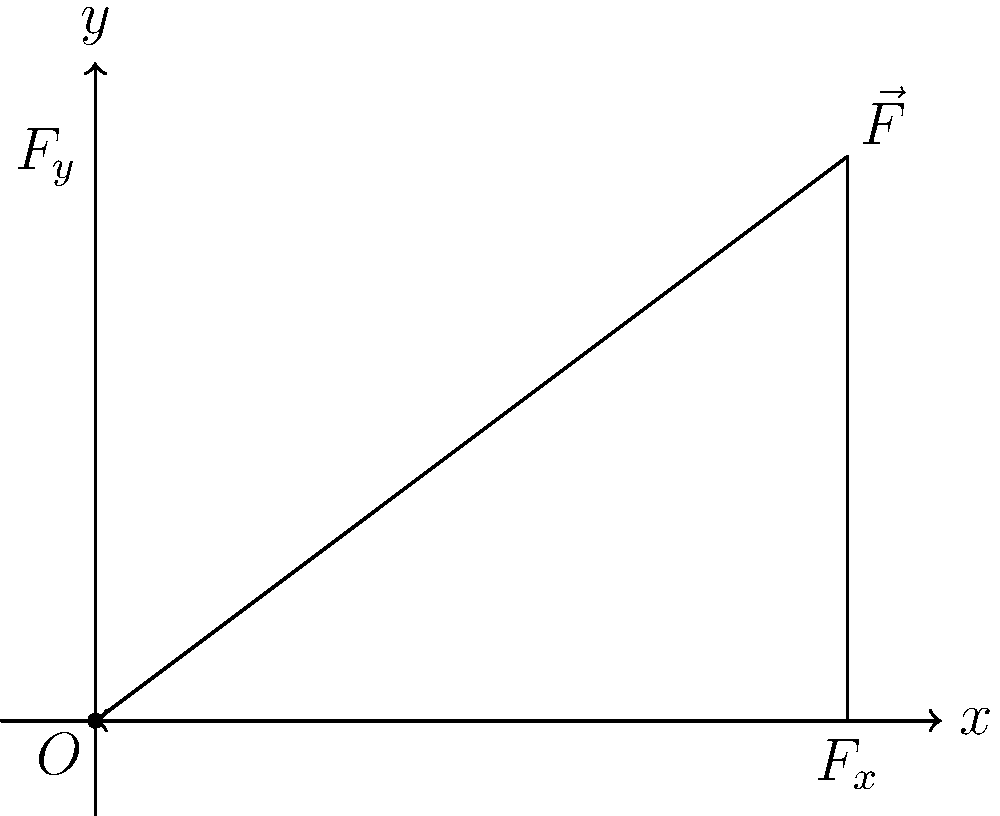As a scientist familiar with vector analysis, consider a force vector $\vec{F}$ with magnitude 5 N acting at an angle of 36.87° above the horizontal, as shown in the figure. Determine the magnitudes of its orthogonal components $F_x$ and $F_y$. To solve this problem, we'll use the trigonometric decomposition of vectors:

1) First, recall the trigonometric relationships for right triangles:
   $\cos \theta = \frac{\text{adjacent}}{\text{hypotenuse}}$ and $\sin \theta = \frac{\text{opposite}}{\text{hypotenuse}}$

2) In this case:
   $|\vec{F}| = 5$ N (hypotenuse)
   $\theta = 36.87°$
   $F_x$ is the adjacent side
   $F_y$ is the opposite side

3) To find $F_x$:
   $F_x = |\vec{F}| \cos \theta = 5 \cos(36.87°) = 5 \times 0.8 = 4$ N

4) To find $F_y$:
   $F_y = |\vec{F}| \sin \theta = 5 \sin(36.87°) = 5 \times 0.6 = 3$ N

5) Verify using the Pythagorean theorem:
   $|\vec{F}|^2 = F_x^2 + F_y^2$
   $5^2 = 4^2 + 3^2$
   $25 = 16 + 9 = 25$ (checks out)

Therefore, the orthogonal components of $\vec{F}$ are $F_x = 4$ N and $F_y = 3$ N.
Answer: $F_x = 4$ N, $F_y = 3$ N 